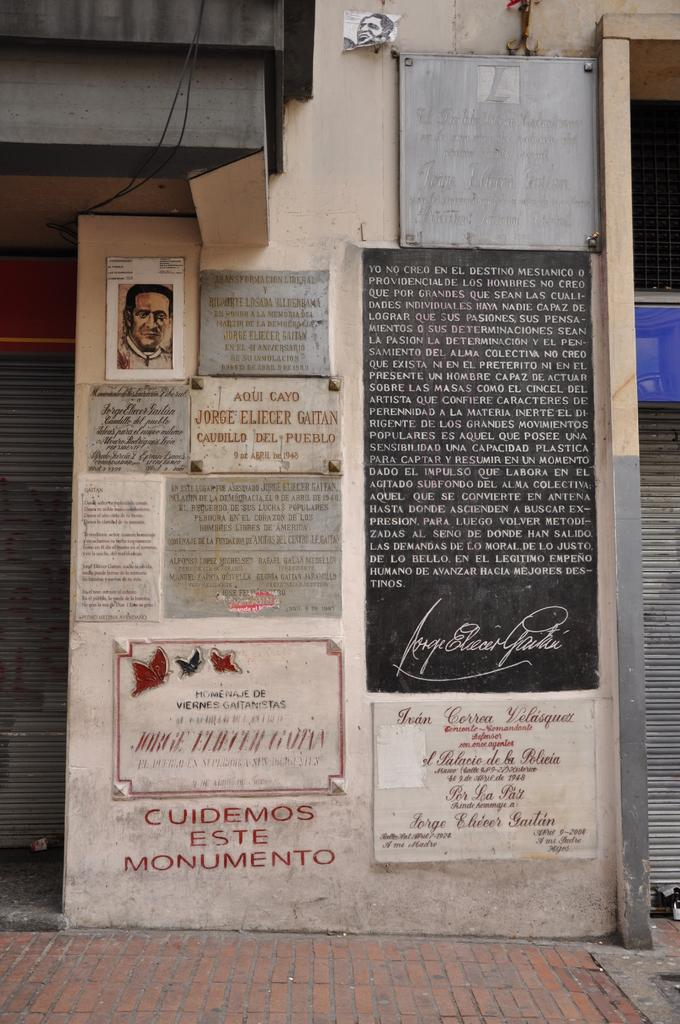What is present on the wall in the image? There are information boards on the wall in the image. What might be the purpose of these information boards? The information boards might be used to display important information or instructions. Can you describe the appearance of the information boards? The information boards are likely rectangular in shape and made of a material such as paper or plastic. What type of throat lozenges are displayed on the information boards in the image? There are no throat lozenges present on the information boards in the image; they are used for displaying information or instructions. 